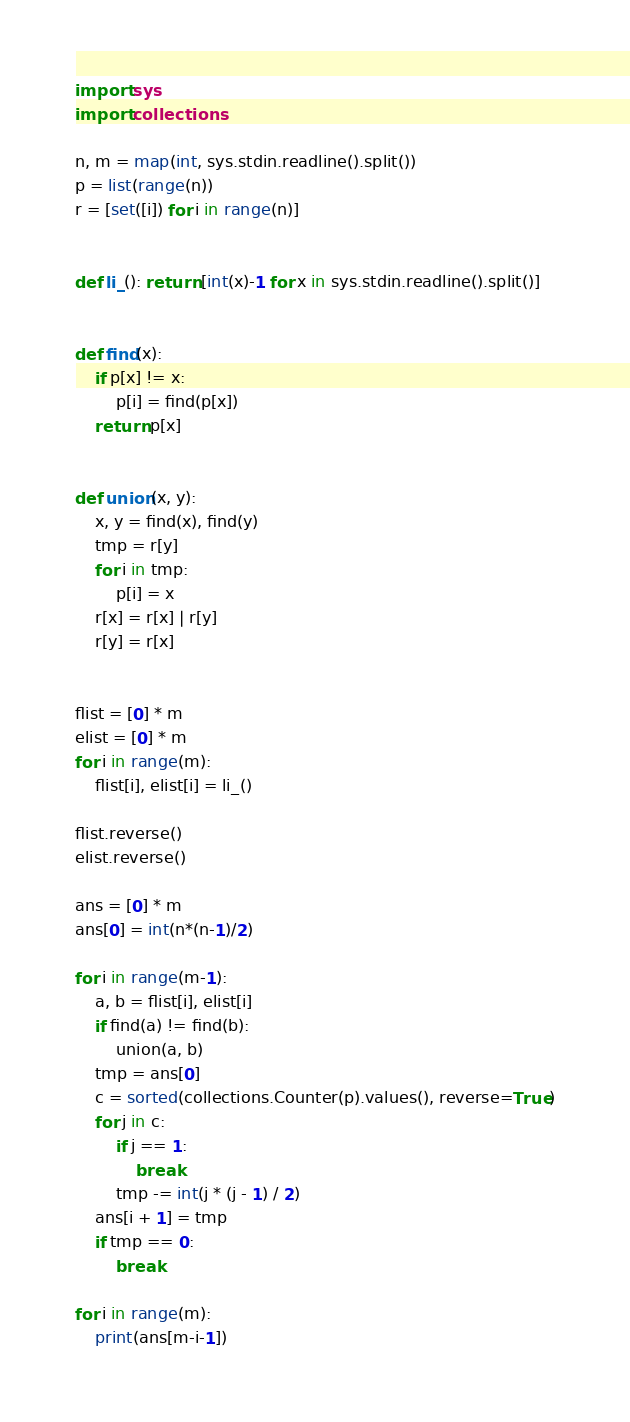Convert code to text. <code><loc_0><loc_0><loc_500><loc_500><_Python_>
import sys
import collections

n, m = map(int, sys.stdin.readline().split())
p = list(range(n))
r = [set([i]) for i in range(n)]


def li_(): return [int(x)-1 for x in sys.stdin.readline().split()]


def find(x):
    if p[x] != x:
        p[i] = find(p[x])
    return p[x]


def union(x, y):
    x, y = find(x), find(y)
    tmp = r[y]
    for i in tmp:
        p[i] = x
    r[x] = r[x] | r[y]
    r[y] = r[x]


flist = [0] * m
elist = [0] * m
for i in range(m):
    flist[i], elist[i] = li_()

flist.reverse()
elist.reverse()

ans = [0] * m
ans[0] = int(n*(n-1)/2)

for i in range(m-1):
    a, b = flist[i], elist[i]
    if find(a) != find(b):
        union(a, b)
    tmp = ans[0]
    c = sorted(collections.Counter(p).values(), reverse=True)
    for j in c:
        if j == 1:
            break
        tmp -= int(j * (j - 1) / 2)
    ans[i + 1] = tmp
    if tmp == 0:
        break

for i in range(m):
    print(ans[m-i-1])
</code> 